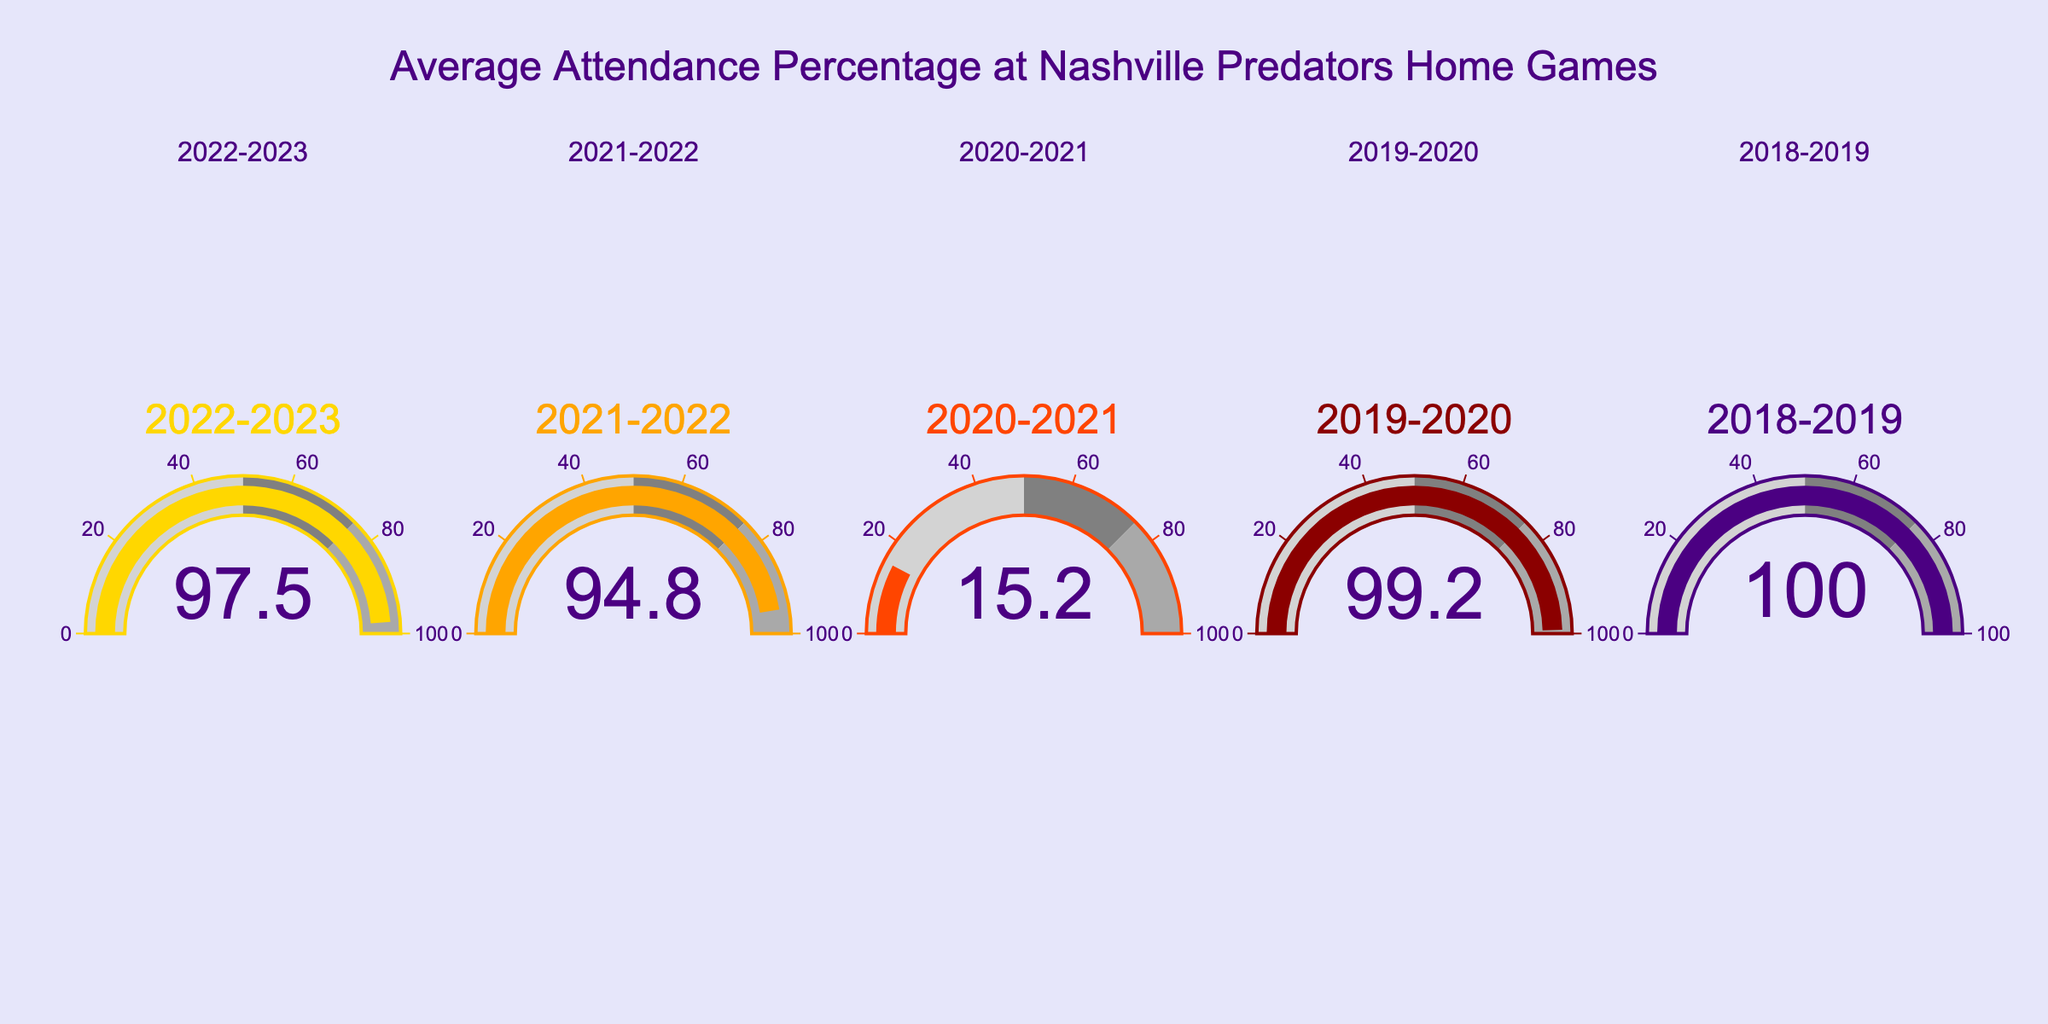What is the average attendance percentage for the 2018-2019 season? The gauge for the 2018-2019 season shows a value of 100%.
Answer: 100% Which season had the lowest attendance percentage? By examining the gauge charts, the 2020-2021 season had the lowest attendance percentage at 15.2%.
Answer: 2020-2021 What is the difference in attendance percentage between the 2019-2020 and 2022-2023 seasons? The attendance percentage for 2019-2020 is 99.2%, and for 2022-2023, it is 97.5%. The difference is calculated as 99.2% - 97.5% = 1.7%.
Answer: 1.7% Across the given seasons, what is the median attendance percentage? The attendance percentages are 15.2%, 94.8%, 97.5%, 99.2%, and 100.0%. Arranging these values in order: 15.2%, 94.8%, 97.5%, 99.2%, 100.0%, the median value is the middle number, which is 97.5%.
Answer: 97.5% How many seasons had an attendance percentage greater than 95%? Examining each gauge, the attendance percentages greater than 95% are for the 2018-2019, 2019-2020, and 2022-2023 seasons. This totals to three seasons.
Answer: 3 Which season came closest to a full 100% attendance? Apart from the 2018-2019 season which has a full 100% attendance, the next closest is the 2019-2020 season with 99.2%.
Answer: 2019-2020 Considering the trend from the 2020-2021 season to the 2022-2023 season, did the attendance percentage improve or decline? From 15.2% in 2020-2021 to 94.8% in 2021-2022 and then to 97.5% in 2022-2023, the attendance percentage showed a consistent improvement.
Answer: Improve What is the range of attendance percentages across all seasons? The minimum attendance percentage is 15.2% (2020-2021), and the maximum is 100.0% (2018-2019). The range is 100.0% - 15.2% = 84.8%.
Answer: 84.8% Which season had an attendance percentage just below 95%? The gauge for the 2021-2022 season shows 94.8%, which is just below 95%.
Answer: 2021-2022 What's the average attendance percentage across all shown seasons? The attendance percentages are 97.5%, 94.8%, 15.2%, 99.2%, and 100.0%. Summing them up gives 97.5 + 94.8 + 15.2 + 99.2 + 100.0 = 406.7. The average is 406.7 / 5 = 81.34%.
Answer: 81.34% 